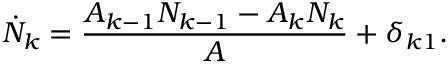Convert formula to latex. <formula><loc_0><loc_0><loc_500><loc_500>\dot { N } _ { k } = \frac { A _ { k - 1 } N _ { k - 1 } - A _ { k } N _ { k } } { A } + \delta _ { k 1 } .</formula> 